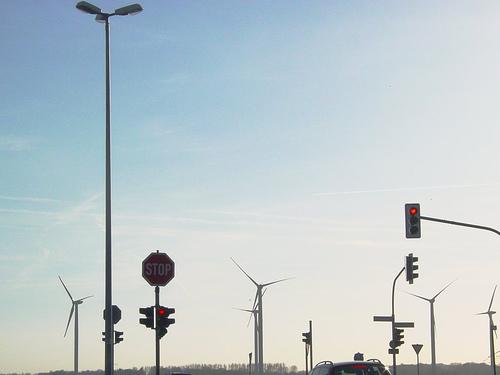Is this an old traffic light?
Answer briefly. No. Are there lots of trees in sight?
Concise answer only. No. How many birds are on the light post on the right?
Short answer required. 0. How far away is the street lamp from the stoplight?
Write a very short answer. 20 feet. Are the vehicles suppose to stop?
Short answer required. Yes. Are any humans in the picture?
Concise answer only. No. Was the pic taken during the night?
Be succinct. No. Is there a mountain in the background?
Write a very short answer. No. What are the windmills used for?
Concise answer only. Energy. Is it cloudy?
Keep it brief. No. Is it day or night?
Answer briefly. Day. 